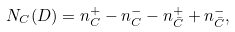<formula> <loc_0><loc_0><loc_500><loc_500>N _ { C } ( D ) = n ^ { + } _ { C } - n ^ { - } _ { C } - n ^ { + } _ { \bar { C } } + n ^ { - } _ { \bar { C } } ,</formula> 